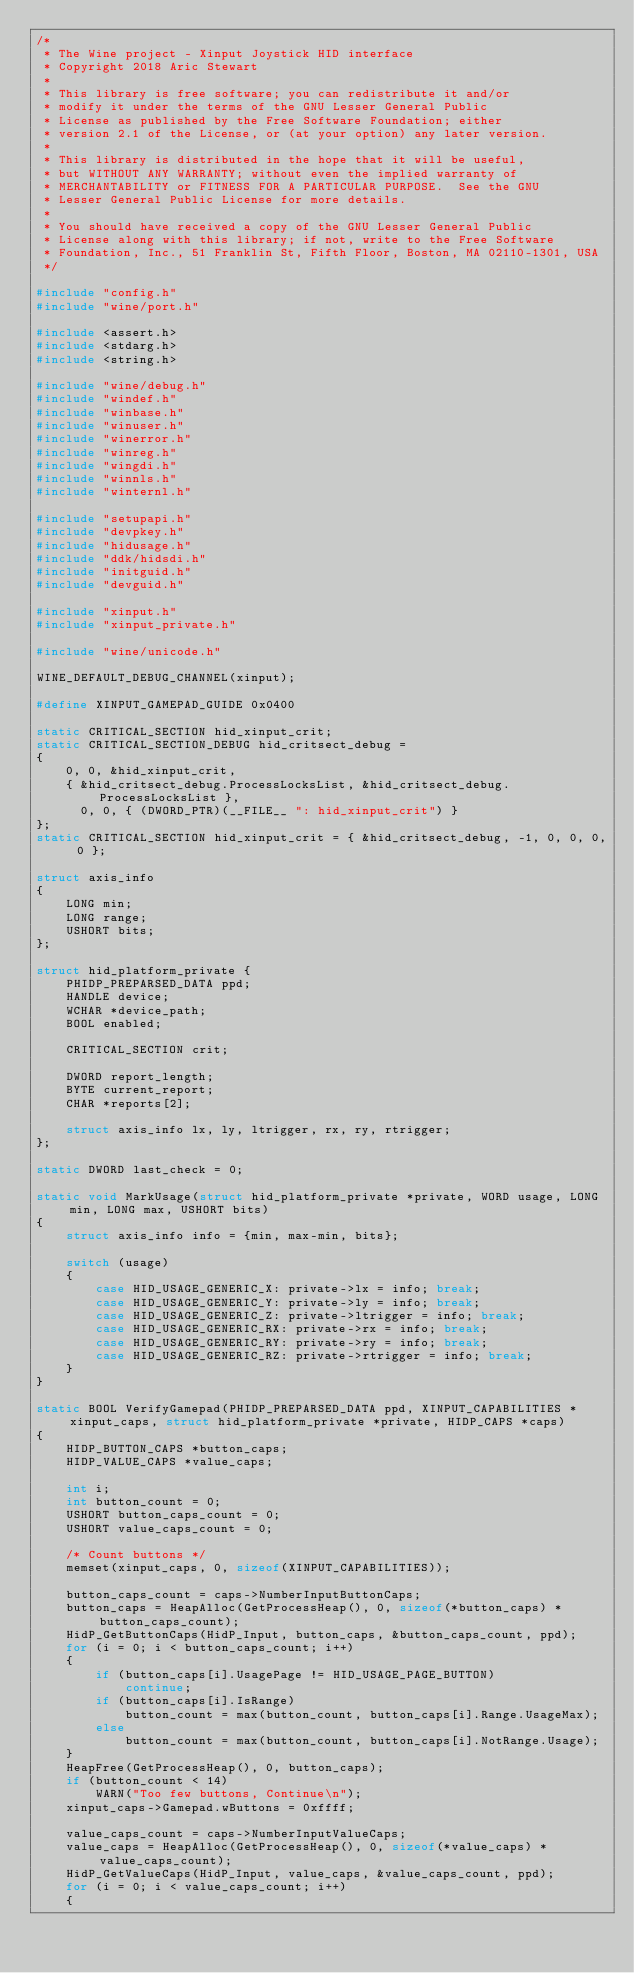Convert code to text. <code><loc_0><loc_0><loc_500><loc_500><_C_>/*
 * The Wine project - Xinput Joystick HID interface
 * Copyright 2018 Aric Stewart
 *
 * This library is free software; you can redistribute it and/or
 * modify it under the terms of the GNU Lesser General Public
 * License as published by the Free Software Foundation; either
 * version 2.1 of the License, or (at your option) any later version.
 *
 * This library is distributed in the hope that it will be useful,
 * but WITHOUT ANY WARRANTY; without even the implied warranty of
 * MERCHANTABILITY or FITNESS FOR A PARTICULAR PURPOSE.  See the GNU
 * Lesser General Public License for more details.
 *
 * You should have received a copy of the GNU Lesser General Public
 * License along with this library; if not, write to the Free Software
 * Foundation, Inc., 51 Franklin St, Fifth Floor, Boston, MA 02110-1301, USA
 */

#include "config.h"
#include "wine/port.h"

#include <assert.h>
#include <stdarg.h>
#include <string.h>

#include "wine/debug.h"
#include "windef.h"
#include "winbase.h"
#include "winuser.h"
#include "winerror.h"
#include "winreg.h"
#include "wingdi.h"
#include "winnls.h"
#include "winternl.h"

#include "setupapi.h"
#include "devpkey.h"
#include "hidusage.h"
#include "ddk/hidsdi.h"
#include "initguid.h"
#include "devguid.h"

#include "xinput.h"
#include "xinput_private.h"

#include "wine/unicode.h"

WINE_DEFAULT_DEBUG_CHANNEL(xinput);

#define XINPUT_GAMEPAD_GUIDE 0x0400

static CRITICAL_SECTION hid_xinput_crit;
static CRITICAL_SECTION_DEBUG hid_critsect_debug =
{
    0, 0, &hid_xinput_crit,
    { &hid_critsect_debug.ProcessLocksList, &hid_critsect_debug.ProcessLocksList },
      0, 0, { (DWORD_PTR)(__FILE__ ": hid_xinput_crit") }
};
static CRITICAL_SECTION hid_xinput_crit = { &hid_critsect_debug, -1, 0, 0, 0, 0 };

struct axis_info
{
    LONG min;
    LONG range;
    USHORT bits;
};

struct hid_platform_private {
    PHIDP_PREPARSED_DATA ppd;
    HANDLE device;
    WCHAR *device_path;
    BOOL enabled;

    CRITICAL_SECTION crit;

    DWORD report_length;
    BYTE current_report;
    CHAR *reports[2];

    struct axis_info lx, ly, ltrigger, rx, ry, rtrigger;
};

static DWORD last_check = 0;

static void MarkUsage(struct hid_platform_private *private, WORD usage, LONG min, LONG max, USHORT bits)
{
    struct axis_info info = {min, max-min, bits};

    switch (usage)
    {
        case HID_USAGE_GENERIC_X: private->lx = info; break;
        case HID_USAGE_GENERIC_Y: private->ly = info; break;
        case HID_USAGE_GENERIC_Z: private->ltrigger = info; break;
        case HID_USAGE_GENERIC_RX: private->rx = info; break;
        case HID_USAGE_GENERIC_RY: private->ry = info; break;
        case HID_USAGE_GENERIC_RZ: private->rtrigger = info; break;
    }
}

static BOOL VerifyGamepad(PHIDP_PREPARSED_DATA ppd, XINPUT_CAPABILITIES *xinput_caps, struct hid_platform_private *private, HIDP_CAPS *caps)
{
    HIDP_BUTTON_CAPS *button_caps;
    HIDP_VALUE_CAPS *value_caps;

    int i;
    int button_count = 0;
    USHORT button_caps_count = 0;
    USHORT value_caps_count = 0;

    /* Count buttons */
    memset(xinput_caps, 0, sizeof(XINPUT_CAPABILITIES));

    button_caps_count = caps->NumberInputButtonCaps;
    button_caps = HeapAlloc(GetProcessHeap(), 0, sizeof(*button_caps) * button_caps_count);
    HidP_GetButtonCaps(HidP_Input, button_caps, &button_caps_count, ppd);
    for (i = 0; i < button_caps_count; i++)
    {
        if (button_caps[i].UsagePage != HID_USAGE_PAGE_BUTTON)
            continue;
        if (button_caps[i].IsRange)
            button_count = max(button_count, button_caps[i].Range.UsageMax);
        else
            button_count = max(button_count, button_caps[i].NotRange.Usage);
    }
    HeapFree(GetProcessHeap(), 0, button_caps);
    if (button_count < 14)
        WARN("Too few buttons, Continue\n");
    xinput_caps->Gamepad.wButtons = 0xffff;

    value_caps_count = caps->NumberInputValueCaps;
    value_caps = HeapAlloc(GetProcessHeap(), 0, sizeof(*value_caps) * value_caps_count);
    HidP_GetValueCaps(HidP_Input, value_caps, &value_caps_count, ppd);
    for (i = 0; i < value_caps_count; i++)
    {</code> 